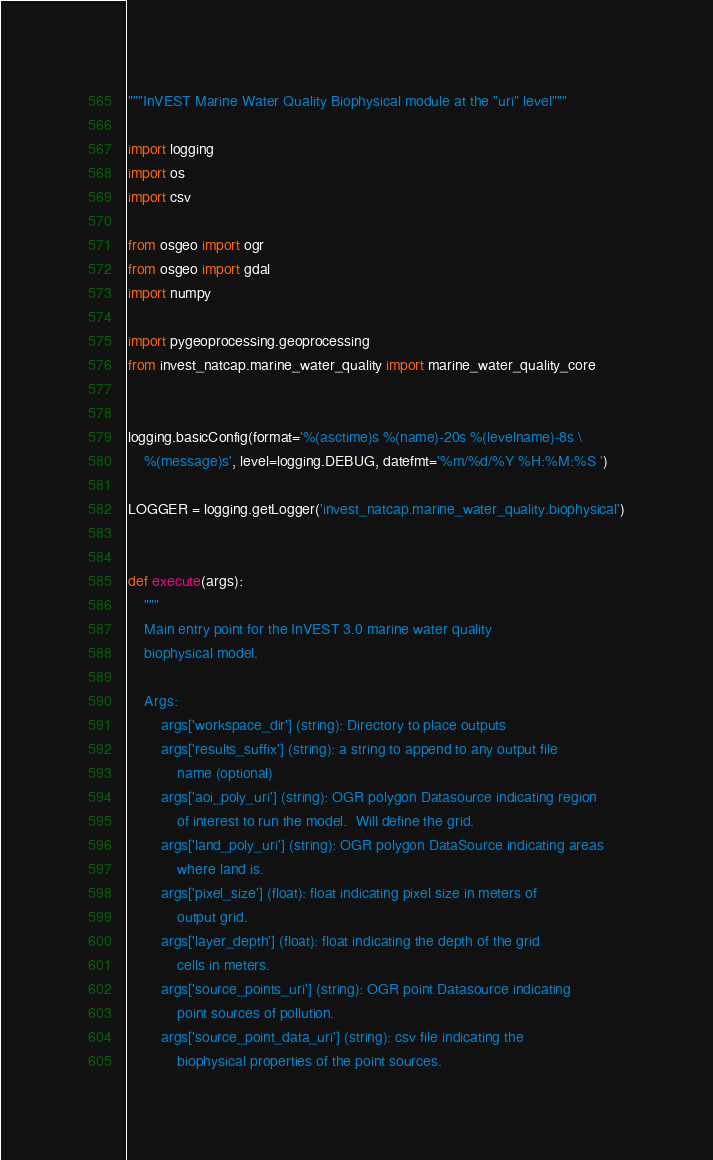<code> <loc_0><loc_0><loc_500><loc_500><_Python_>"""InVEST Marine Water Quality Biophysical module at the "uri" level"""

import logging
import os
import csv

from osgeo import ogr
from osgeo import gdal
import numpy

import pygeoprocessing.geoprocessing
from invest_natcap.marine_water_quality import marine_water_quality_core


logging.basicConfig(format='%(asctime)s %(name)-20s %(levelname)-8s \
    %(message)s', level=logging.DEBUG, datefmt='%m/%d/%Y %H:%M:%S ')

LOGGER = logging.getLogger('invest_natcap.marine_water_quality.biophysical')


def execute(args):
    """
    Main entry point for the InVEST 3.0 marine water quality
    biophysical model.

    Args:
        args['workspace_dir'] (string): Directory to place outputs
        args['results_suffix'] (string): a string to append to any output file
            name (optional)
        args['aoi_poly_uri'] (string): OGR polygon Datasource indicating region
            of interest to run the model.  Will define the grid.
        args['land_poly_uri'] (string): OGR polygon DataSource indicating areas
            where land is.
        args['pixel_size'] (float): float indicating pixel size in meters of
            output grid.
        args['layer_depth'] (float): float indicating the depth of the grid
            cells in meters.
        args['source_points_uri'] (string): OGR point Datasource indicating
            point sources of pollution.
        args['source_point_data_uri'] (string): csv file indicating the
            biophysical properties of the point sources.</code> 